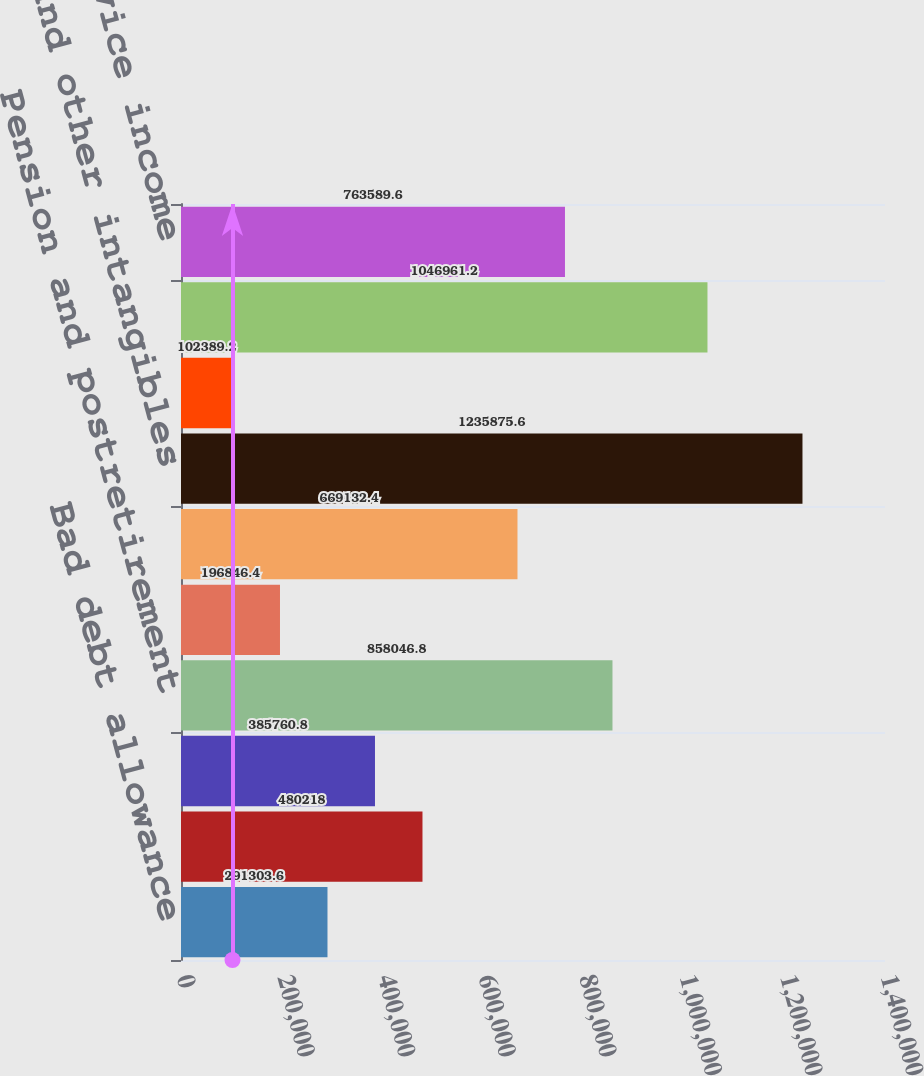Convert chart to OTSL. <chart><loc_0><loc_0><loc_500><loc_500><bar_chart><fcel>Bad debt allowance<fcel>Inventories<fcel>Property plant and equipment<fcel>Pension and postretirement<fcel>Insurance including self -<fcel>Basis difference in LYONs<fcel>Goodwill and other intangibles<fcel>Environmental and regulatory<fcel>Other accruals and prepayments<fcel>Deferred service income<nl><fcel>291304<fcel>480218<fcel>385761<fcel>858047<fcel>196846<fcel>669132<fcel>1.23588e+06<fcel>102389<fcel>1.04696e+06<fcel>763590<nl></chart> 